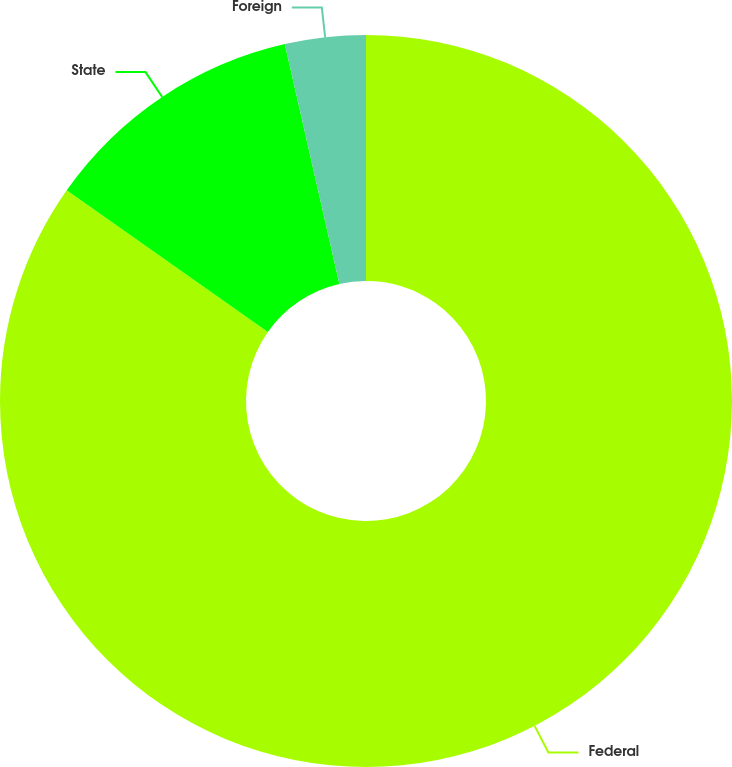<chart> <loc_0><loc_0><loc_500><loc_500><pie_chart><fcel>Federal<fcel>State<fcel>Foreign<nl><fcel>84.77%<fcel>11.68%<fcel>3.56%<nl></chart> 